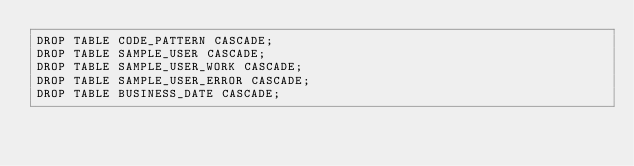<code> <loc_0><loc_0><loc_500><loc_500><_SQL_>DROP TABLE CODE_PATTERN CASCADE;
DROP TABLE SAMPLE_USER CASCADE;
DROP TABLE SAMPLE_USER_WORK CASCADE;
DROP TABLE SAMPLE_USER_ERROR CASCADE;
DROP TABLE BUSINESS_DATE CASCADE;
</code> 